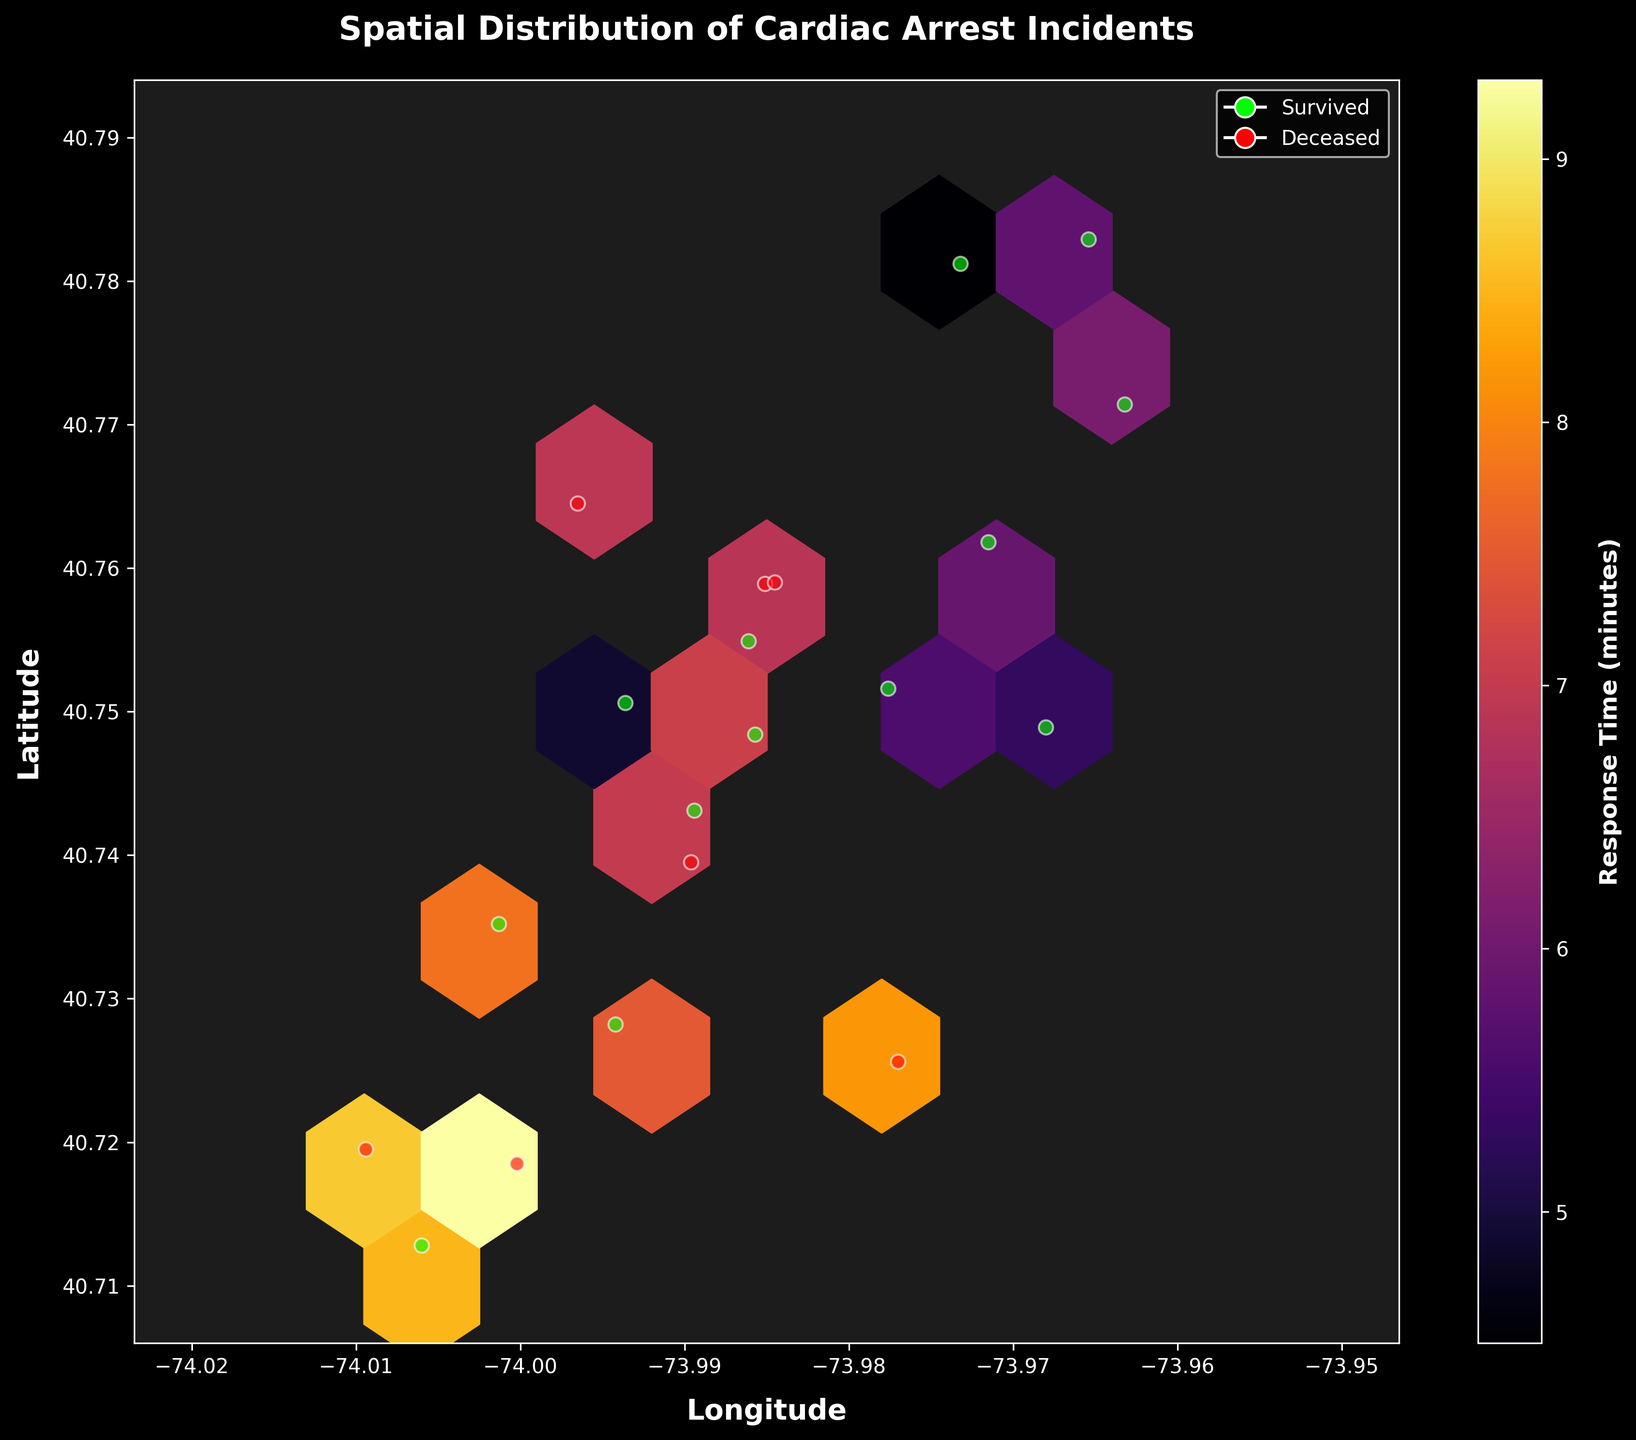What is the title of the figure? The title is usually located at the top of the figure. In this case, it reads "Spatial Distribution of Cardiac Arrest Incidents".
Answer: Spatial Distribution of Cardiac Arrest Incidents What do the colors represent in the hexbin plot? The colorbar legend on the right side of the figure indicates that the colors represent "Response Time (minutes)". The darker the color, the higher the response time.
Answer: Response Time (minutes) What are the axes labels in the plot? The labels for the axes are shown along each axis. The x-axis is labeled "Longitude" and the y-axis is labeled "Latitude".
Answer: Longitude and Latitude How many different outcomes are denoted by the scatter points, and how are they represented? The scatter points represent two outcomes, "Survived" and "Deceased". "Survived" is denoted by lime green points and "Deceased" by red points, as indicated by the legend on the plot.
Answer: Two; Survived (lime) and Deceased (red) What is the range of response times represented in the plot? The range can be inferred from the colorbar. It starts from the lowest value, depicted in a lighter color, and goes up to the highest value in a darker color. According to the colorbar, the range is from approximately 4.5 to 9.5 minutes.
Answer: Approximately 4.5 to 9.5 minutes Which location shows the longest response time? By observing the darkest hexbin area in the plot, we can identify the location with the longest response time. It is in the lower-left region of the plot, closer to Latitude 40.71 and Longitude -74.00.
Answer: Latitude 40.71, Longitude -74.00 Does there appear to be more incidents with 'Survived' or 'Deceased' outcomes? By counting the scatter points, we can visually assess that there are more lime green points (Survived) than red points (Deceased) in the plot.
Answer: More Survived outcomes What region has the highest density of cardiac arrest incidents? The densest region can be identified by the area with the most concentrated hexbin clusters. This is around the central part of the plot, near Latitude 40.75 and Longitude -73.99.
Answer: Latitude 40.75, Longitude -73.99 Are there any regions with low response times and a high survival rate? We can look for lighter colored hexbin regions (indicating low response times) with a higher number of lime green scatter points (indicating survived cases). There are some areas in the central and northern parts of the plot showing these characteristics.
Answer: Central and northern parts Based on the visual data, would you say higher response times correlate with the outcome of 'Deceased'? By analyzing the darker hexbin areas where the response times are higher and checking the color of scatter points, we see a pattern of more red points (Deceased) in these regions. This suggests that higher response times might correlate with 'Deceased' outcomes.
Answer: Yes 